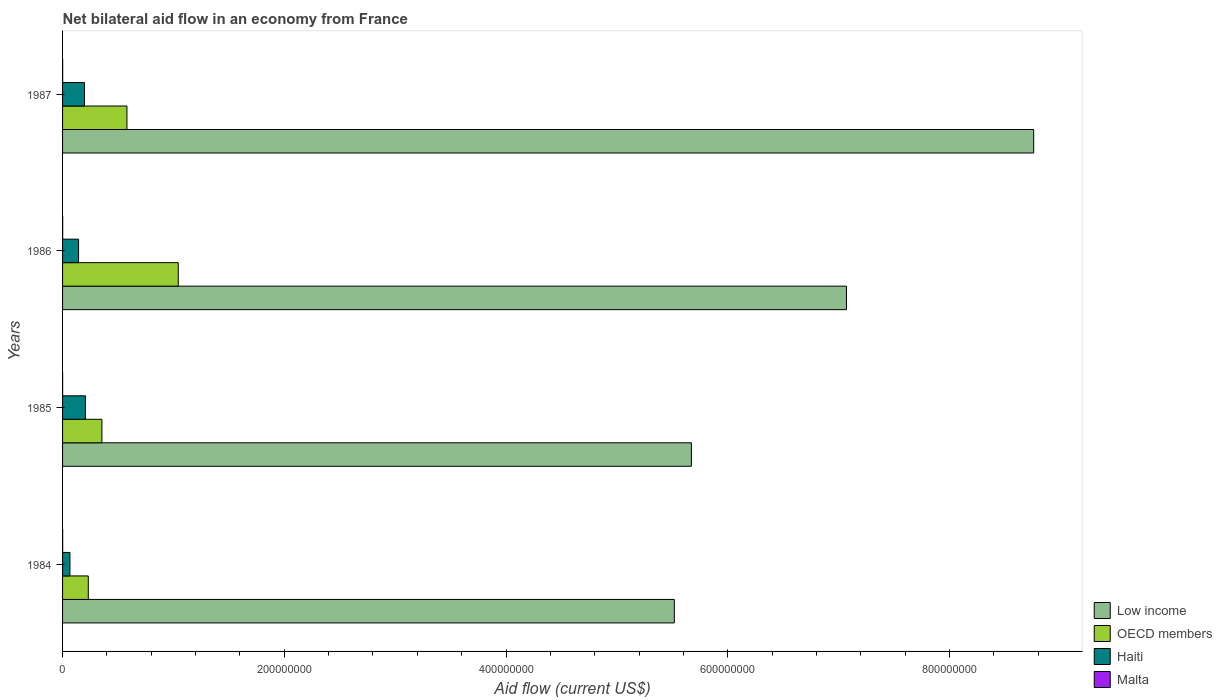How many different coloured bars are there?
Provide a short and direct response. 4. How many groups of bars are there?
Provide a short and direct response. 4. What is the net bilateral aid flow in Haiti in 1987?
Provide a succinct answer. 1.98e+07. Across all years, what is the maximum net bilateral aid flow in OECD members?
Provide a short and direct response. 1.04e+08. Across all years, what is the minimum net bilateral aid flow in Malta?
Provide a succinct answer. 5.00e+04. In which year was the net bilateral aid flow in Malta maximum?
Your answer should be very brief. 1986. In which year was the net bilateral aid flow in OECD members minimum?
Your answer should be compact. 1984. What is the total net bilateral aid flow in Haiti in the graph?
Your response must be concise. 6.15e+07. What is the difference between the net bilateral aid flow in OECD members in 1987 and the net bilateral aid flow in Malta in 1984?
Give a very brief answer. 5.80e+07. What is the average net bilateral aid flow in Low income per year?
Ensure brevity in your answer.  6.76e+08. In the year 1984, what is the difference between the net bilateral aid flow in Haiti and net bilateral aid flow in Malta?
Ensure brevity in your answer.  6.56e+06. What is the ratio of the net bilateral aid flow in OECD members in 1984 to that in 1985?
Give a very brief answer. 0.65. Is the net bilateral aid flow in OECD members in 1985 less than that in 1987?
Keep it short and to the point. Yes. Is the difference between the net bilateral aid flow in Haiti in 1986 and 1987 greater than the difference between the net bilateral aid flow in Malta in 1986 and 1987?
Offer a very short reply. No. What is the difference between the highest and the second highest net bilateral aid flow in Low income?
Your answer should be very brief. 1.69e+08. What is the difference between the highest and the lowest net bilateral aid flow in Low income?
Make the answer very short. 3.24e+08. Are all the bars in the graph horizontal?
Offer a terse response. Yes. How many years are there in the graph?
Ensure brevity in your answer.  4. Does the graph contain any zero values?
Offer a very short reply. No. Does the graph contain grids?
Provide a short and direct response. No. Where does the legend appear in the graph?
Your answer should be very brief. Bottom right. What is the title of the graph?
Make the answer very short. Net bilateral aid flow in an economy from France. Does "South Asia" appear as one of the legend labels in the graph?
Your response must be concise. No. What is the label or title of the Y-axis?
Give a very brief answer. Years. What is the Aid flow (current US$) in Low income in 1984?
Your answer should be compact. 5.52e+08. What is the Aid flow (current US$) of OECD members in 1984?
Offer a very short reply. 2.32e+07. What is the Aid flow (current US$) in Haiti in 1984?
Offer a very short reply. 6.66e+06. What is the Aid flow (current US$) in Low income in 1985?
Make the answer very short. 5.67e+08. What is the Aid flow (current US$) of OECD members in 1985?
Keep it short and to the point. 3.55e+07. What is the Aid flow (current US$) in Haiti in 1985?
Give a very brief answer. 2.06e+07. What is the Aid flow (current US$) in Low income in 1986?
Give a very brief answer. 7.07e+08. What is the Aid flow (current US$) in OECD members in 1986?
Provide a succinct answer. 1.04e+08. What is the Aid flow (current US$) in Haiti in 1986?
Give a very brief answer. 1.44e+07. What is the Aid flow (current US$) in Malta in 1986?
Give a very brief answer. 1.10e+05. What is the Aid flow (current US$) of Low income in 1987?
Offer a very short reply. 8.76e+08. What is the Aid flow (current US$) in OECD members in 1987?
Keep it short and to the point. 5.81e+07. What is the Aid flow (current US$) in Haiti in 1987?
Your response must be concise. 1.98e+07. What is the Aid flow (current US$) of Malta in 1987?
Offer a terse response. 1.00e+05. Across all years, what is the maximum Aid flow (current US$) of Low income?
Provide a short and direct response. 8.76e+08. Across all years, what is the maximum Aid flow (current US$) in OECD members?
Provide a short and direct response. 1.04e+08. Across all years, what is the maximum Aid flow (current US$) of Haiti?
Ensure brevity in your answer.  2.06e+07. Across all years, what is the minimum Aid flow (current US$) in Low income?
Your answer should be very brief. 5.52e+08. Across all years, what is the minimum Aid flow (current US$) of OECD members?
Provide a short and direct response. 2.32e+07. Across all years, what is the minimum Aid flow (current US$) of Haiti?
Your response must be concise. 6.66e+06. Across all years, what is the minimum Aid flow (current US$) in Malta?
Offer a very short reply. 5.00e+04. What is the total Aid flow (current US$) in Low income in the graph?
Make the answer very short. 2.70e+09. What is the total Aid flow (current US$) in OECD members in the graph?
Make the answer very short. 2.21e+08. What is the total Aid flow (current US$) of Haiti in the graph?
Ensure brevity in your answer.  6.15e+07. What is the difference between the Aid flow (current US$) in Low income in 1984 and that in 1985?
Offer a very short reply. -1.54e+07. What is the difference between the Aid flow (current US$) of OECD members in 1984 and that in 1985?
Your answer should be compact. -1.23e+07. What is the difference between the Aid flow (current US$) of Haiti in 1984 and that in 1985?
Your response must be concise. -1.40e+07. What is the difference between the Aid flow (current US$) of Malta in 1984 and that in 1985?
Make the answer very short. 5.00e+04. What is the difference between the Aid flow (current US$) in Low income in 1984 and that in 1986?
Provide a succinct answer. -1.55e+08. What is the difference between the Aid flow (current US$) in OECD members in 1984 and that in 1986?
Offer a terse response. -8.12e+07. What is the difference between the Aid flow (current US$) of Haiti in 1984 and that in 1986?
Offer a very short reply. -7.78e+06. What is the difference between the Aid flow (current US$) in Low income in 1984 and that in 1987?
Ensure brevity in your answer.  -3.24e+08. What is the difference between the Aid flow (current US$) in OECD members in 1984 and that in 1987?
Your answer should be compact. -3.49e+07. What is the difference between the Aid flow (current US$) in Haiti in 1984 and that in 1987?
Ensure brevity in your answer.  -1.31e+07. What is the difference between the Aid flow (current US$) in Low income in 1985 and that in 1986?
Provide a succinct answer. -1.40e+08. What is the difference between the Aid flow (current US$) of OECD members in 1985 and that in 1986?
Your response must be concise. -6.89e+07. What is the difference between the Aid flow (current US$) in Haiti in 1985 and that in 1986?
Provide a short and direct response. 6.19e+06. What is the difference between the Aid flow (current US$) in Malta in 1985 and that in 1986?
Provide a succinct answer. -6.00e+04. What is the difference between the Aid flow (current US$) of Low income in 1985 and that in 1987?
Offer a terse response. -3.09e+08. What is the difference between the Aid flow (current US$) in OECD members in 1985 and that in 1987?
Ensure brevity in your answer.  -2.26e+07. What is the difference between the Aid flow (current US$) in Haiti in 1985 and that in 1987?
Your answer should be very brief. 8.80e+05. What is the difference between the Aid flow (current US$) of Low income in 1986 and that in 1987?
Offer a very short reply. -1.69e+08. What is the difference between the Aid flow (current US$) in OECD members in 1986 and that in 1987?
Offer a terse response. 4.63e+07. What is the difference between the Aid flow (current US$) in Haiti in 1986 and that in 1987?
Offer a terse response. -5.31e+06. What is the difference between the Aid flow (current US$) of Malta in 1986 and that in 1987?
Your answer should be compact. 10000. What is the difference between the Aid flow (current US$) in Low income in 1984 and the Aid flow (current US$) in OECD members in 1985?
Give a very brief answer. 5.16e+08. What is the difference between the Aid flow (current US$) in Low income in 1984 and the Aid flow (current US$) in Haiti in 1985?
Offer a terse response. 5.31e+08. What is the difference between the Aid flow (current US$) in Low income in 1984 and the Aid flow (current US$) in Malta in 1985?
Ensure brevity in your answer.  5.52e+08. What is the difference between the Aid flow (current US$) of OECD members in 1984 and the Aid flow (current US$) of Haiti in 1985?
Provide a succinct answer. 2.58e+06. What is the difference between the Aid flow (current US$) of OECD members in 1984 and the Aid flow (current US$) of Malta in 1985?
Provide a short and direct response. 2.32e+07. What is the difference between the Aid flow (current US$) of Haiti in 1984 and the Aid flow (current US$) of Malta in 1985?
Provide a succinct answer. 6.61e+06. What is the difference between the Aid flow (current US$) in Low income in 1984 and the Aid flow (current US$) in OECD members in 1986?
Your answer should be very brief. 4.47e+08. What is the difference between the Aid flow (current US$) of Low income in 1984 and the Aid flow (current US$) of Haiti in 1986?
Offer a terse response. 5.37e+08. What is the difference between the Aid flow (current US$) of Low income in 1984 and the Aid flow (current US$) of Malta in 1986?
Ensure brevity in your answer.  5.52e+08. What is the difference between the Aid flow (current US$) of OECD members in 1984 and the Aid flow (current US$) of Haiti in 1986?
Give a very brief answer. 8.77e+06. What is the difference between the Aid flow (current US$) of OECD members in 1984 and the Aid flow (current US$) of Malta in 1986?
Give a very brief answer. 2.31e+07. What is the difference between the Aid flow (current US$) of Haiti in 1984 and the Aid flow (current US$) of Malta in 1986?
Your answer should be compact. 6.55e+06. What is the difference between the Aid flow (current US$) in Low income in 1984 and the Aid flow (current US$) in OECD members in 1987?
Make the answer very short. 4.94e+08. What is the difference between the Aid flow (current US$) of Low income in 1984 and the Aid flow (current US$) of Haiti in 1987?
Provide a succinct answer. 5.32e+08. What is the difference between the Aid flow (current US$) in Low income in 1984 and the Aid flow (current US$) in Malta in 1987?
Provide a succinct answer. 5.52e+08. What is the difference between the Aid flow (current US$) in OECD members in 1984 and the Aid flow (current US$) in Haiti in 1987?
Your answer should be compact. 3.46e+06. What is the difference between the Aid flow (current US$) of OECD members in 1984 and the Aid flow (current US$) of Malta in 1987?
Ensure brevity in your answer.  2.31e+07. What is the difference between the Aid flow (current US$) in Haiti in 1984 and the Aid flow (current US$) in Malta in 1987?
Offer a very short reply. 6.56e+06. What is the difference between the Aid flow (current US$) of Low income in 1985 and the Aid flow (current US$) of OECD members in 1986?
Make the answer very short. 4.63e+08. What is the difference between the Aid flow (current US$) of Low income in 1985 and the Aid flow (current US$) of Haiti in 1986?
Ensure brevity in your answer.  5.53e+08. What is the difference between the Aid flow (current US$) of Low income in 1985 and the Aid flow (current US$) of Malta in 1986?
Give a very brief answer. 5.67e+08. What is the difference between the Aid flow (current US$) of OECD members in 1985 and the Aid flow (current US$) of Haiti in 1986?
Offer a very short reply. 2.10e+07. What is the difference between the Aid flow (current US$) of OECD members in 1985 and the Aid flow (current US$) of Malta in 1986?
Offer a very short reply. 3.54e+07. What is the difference between the Aid flow (current US$) of Haiti in 1985 and the Aid flow (current US$) of Malta in 1986?
Your answer should be compact. 2.05e+07. What is the difference between the Aid flow (current US$) of Low income in 1985 and the Aid flow (current US$) of OECD members in 1987?
Your response must be concise. 5.09e+08. What is the difference between the Aid flow (current US$) in Low income in 1985 and the Aid flow (current US$) in Haiti in 1987?
Offer a terse response. 5.47e+08. What is the difference between the Aid flow (current US$) of Low income in 1985 and the Aid flow (current US$) of Malta in 1987?
Provide a short and direct response. 5.67e+08. What is the difference between the Aid flow (current US$) of OECD members in 1985 and the Aid flow (current US$) of Haiti in 1987?
Provide a short and direct response. 1.57e+07. What is the difference between the Aid flow (current US$) of OECD members in 1985 and the Aid flow (current US$) of Malta in 1987?
Ensure brevity in your answer.  3.54e+07. What is the difference between the Aid flow (current US$) in Haiti in 1985 and the Aid flow (current US$) in Malta in 1987?
Your answer should be very brief. 2.05e+07. What is the difference between the Aid flow (current US$) of Low income in 1986 and the Aid flow (current US$) of OECD members in 1987?
Provide a succinct answer. 6.49e+08. What is the difference between the Aid flow (current US$) in Low income in 1986 and the Aid flow (current US$) in Haiti in 1987?
Provide a succinct answer. 6.87e+08. What is the difference between the Aid flow (current US$) in Low income in 1986 and the Aid flow (current US$) in Malta in 1987?
Offer a very short reply. 7.07e+08. What is the difference between the Aid flow (current US$) in OECD members in 1986 and the Aid flow (current US$) in Haiti in 1987?
Your response must be concise. 8.46e+07. What is the difference between the Aid flow (current US$) of OECD members in 1986 and the Aid flow (current US$) of Malta in 1987?
Ensure brevity in your answer.  1.04e+08. What is the difference between the Aid flow (current US$) of Haiti in 1986 and the Aid flow (current US$) of Malta in 1987?
Ensure brevity in your answer.  1.43e+07. What is the average Aid flow (current US$) of Low income per year?
Offer a terse response. 6.76e+08. What is the average Aid flow (current US$) of OECD members per year?
Your answer should be compact. 5.53e+07. What is the average Aid flow (current US$) of Haiti per year?
Make the answer very short. 1.54e+07. In the year 1984, what is the difference between the Aid flow (current US$) in Low income and Aid flow (current US$) in OECD members?
Make the answer very short. 5.29e+08. In the year 1984, what is the difference between the Aid flow (current US$) of Low income and Aid flow (current US$) of Haiti?
Provide a succinct answer. 5.45e+08. In the year 1984, what is the difference between the Aid flow (current US$) of Low income and Aid flow (current US$) of Malta?
Your answer should be very brief. 5.52e+08. In the year 1984, what is the difference between the Aid flow (current US$) of OECD members and Aid flow (current US$) of Haiti?
Your answer should be compact. 1.66e+07. In the year 1984, what is the difference between the Aid flow (current US$) of OECD members and Aid flow (current US$) of Malta?
Ensure brevity in your answer.  2.31e+07. In the year 1984, what is the difference between the Aid flow (current US$) in Haiti and Aid flow (current US$) in Malta?
Provide a succinct answer. 6.56e+06. In the year 1985, what is the difference between the Aid flow (current US$) of Low income and Aid flow (current US$) of OECD members?
Keep it short and to the point. 5.32e+08. In the year 1985, what is the difference between the Aid flow (current US$) in Low income and Aid flow (current US$) in Haiti?
Offer a terse response. 5.47e+08. In the year 1985, what is the difference between the Aid flow (current US$) in Low income and Aid flow (current US$) in Malta?
Keep it short and to the point. 5.67e+08. In the year 1985, what is the difference between the Aid flow (current US$) of OECD members and Aid flow (current US$) of Haiti?
Your answer should be very brief. 1.49e+07. In the year 1985, what is the difference between the Aid flow (current US$) of OECD members and Aid flow (current US$) of Malta?
Offer a very short reply. 3.54e+07. In the year 1985, what is the difference between the Aid flow (current US$) in Haiti and Aid flow (current US$) in Malta?
Keep it short and to the point. 2.06e+07. In the year 1986, what is the difference between the Aid flow (current US$) in Low income and Aid flow (current US$) in OECD members?
Provide a succinct answer. 6.03e+08. In the year 1986, what is the difference between the Aid flow (current US$) of Low income and Aid flow (current US$) of Haiti?
Make the answer very short. 6.93e+08. In the year 1986, what is the difference between the Aid flow (current US$) in Low income and Aid flow (current US$) in Malta?
Provide a short and direct response. 7.07e+08. In the year 1986, what is the difference between the Aid flow (current US$) of OECD members and Aid flow (current US$) of Haiti?
Make the answer very short. 8.99e+07. In the year 1986, what is the difference between the Aid flow (current US$) of OECD members and Aid flow (current US$) of Malta?
Keep it short and to the point. 1.04e+08. In the year 1986, what is the difference between the Aid flow (current US$) of Haiti and Aid flow (current US$) of Malta?
Keep it short and to the point. 1.43e+07. In the year 1987, what is the difference between the Aid flow (current US$) in Low income and Aid flow (current US$) in OECD members?
Offer a very short reply. 8.18e+08. In the year 1987, what is the difference between the Aid flow (current US$) in Low income and Aid flow (current US$) in Haiti?
Keep it short and to the point. 8.56e+08. In the year 1987, what is the difference between the Aid flow (current US$) of Low income and Aid flow (current US$) of Malta?
Offer a very short reply. 8.76e+08. In the year 1987, what is the difference between the Aid flow (current US$) of OECD members and Aid flow (current US$) of Haiti?
Offer a terse response. 3.83e+07. In the year 1987, what is the difference between the Aid flow (current US$) of OECD members and Aid flow (current US$) of Malta?
Your answer should be very brief. 5.80e+07. In the year 1987, what is the difference between the Aid flow (current US$) in Haiti and Aid flow (current US$) in Malta?
Your response must be concise. 1.96e+07. What is the ratio of the Aid flow (current US$) of Low income in 1984 to that in 1985?
Keep it short and to the point. 0.97. What is the ratio of the Aid flow (current US$) in OECD members in 1984 to that in 1985?
Provide a short and direct response. 0.65. What is the ratio of the Aid flow (current US$) in Haiti in 1984 to that in 1985?
Offer a terse response. 0.32. What is the ratio of the Aid flow (current US$) of Malta in 1984 to that in 1985?
Your response must be concise. 2. What is the ratio of the Aid flow (current US$) in Low income in 1984 to that in 1986?
Your answer should be compact. 0.78. What is the ratio of the Aid flow (current US$) in OECD members in 1984 to that in 1986?
Ensure brevity in your answer.  0.22. What is the ratio of the Aid flow (current US$) in Haiti in 1984 to that in 1986?
Provide a succinct answer. 0.46. What is the ratio of the Aid flow (current US$) in Low income in 1984 to that in 1987?
Your answer should be very brief. 0.63. What is the ratio of the Aid flow (current US$) of OECD members in 1984 to that in 1987?
Ensure brevity in your answer.  0.4. What is the ratio of the Aid flow (current US$) of Haiti in 1984 to that in 1987?
Offer a terse response. 0.34. What is the ratio of the Aid flow (current US$) in Malta in 1984 to that in 1987?
Your response must be concise. 1. What is the ratio of the Aid flow (current US$) in Low income in 1985 to that in 1986?
Keep it short and to the point. 0.8. What is the ratio of the Aid flow (current US$) of OECD members in 1985 to that in 1986?
Your response must be concise. 0.34. What is the ratio of the Aid flow (current US$) of Haiti in 1985 to that in 1986?
Make the answer very short. 1.43. What is the ratio of the Aid flow (current US$) of Malta in 1985 to that in 1986?
Provide a succinct answer. 0.45. What is the ratio of the Aid flow (current US$) of Low income in 1985 to that in 1987?
Offer a terse response. 0.65. What is the ratio of the Aid flow (current US$) in OECD members in 1985 to that in 1987?
Make the answer very short. 0.61. What is the ratio of the Aid flow (current US$) of Haiti in 1985 to that in 1987?
Keep it short and to the point. 1.04. What is the ratio of the Aid flow (current US$) of Low income in 1986 to that in 1987?
Offer a very short reply. 0.81. What is the ratio of the Aid flow (current US$) in OECD members in 1986 to that in 1987?
Keep it short and to the point. 1.8. What is the ratio of the Aid flow (current US$) in Haiti in 1986 to that in 1987?
Provide a short and direct response. 0.73. What is the difference between the highest and the second highest Aid flow (current US$) of Low income?
Make the answer very short. 1.69e+08. What is the difference between the highest and the second highest Aid flow (current US$) in OECD members?
Provide a short and direct response. 4.63e+07. What is the difference between the highest and the second highest Aid flow (current US$) in Haiti?
Provide a succinct answer. 8.80e+05. What is the difference between the highest and the lowest Aid flow (current US$) in Low income?
Offer a very short reply. 3.24e+08. What is the difference between the highest and the lowest Aid flow (current US$) in OECD members?
Your response must be concise. 8.12e+07. What is the difference between the highest and the lowest Aid flow (current US$) of Haiti?
Offer a terse response. 1.40e+07. What is the difference between the highest and the lowest Aid flow (current US$) in Malta?
Provide a short and direct response. 6.00e+04. 